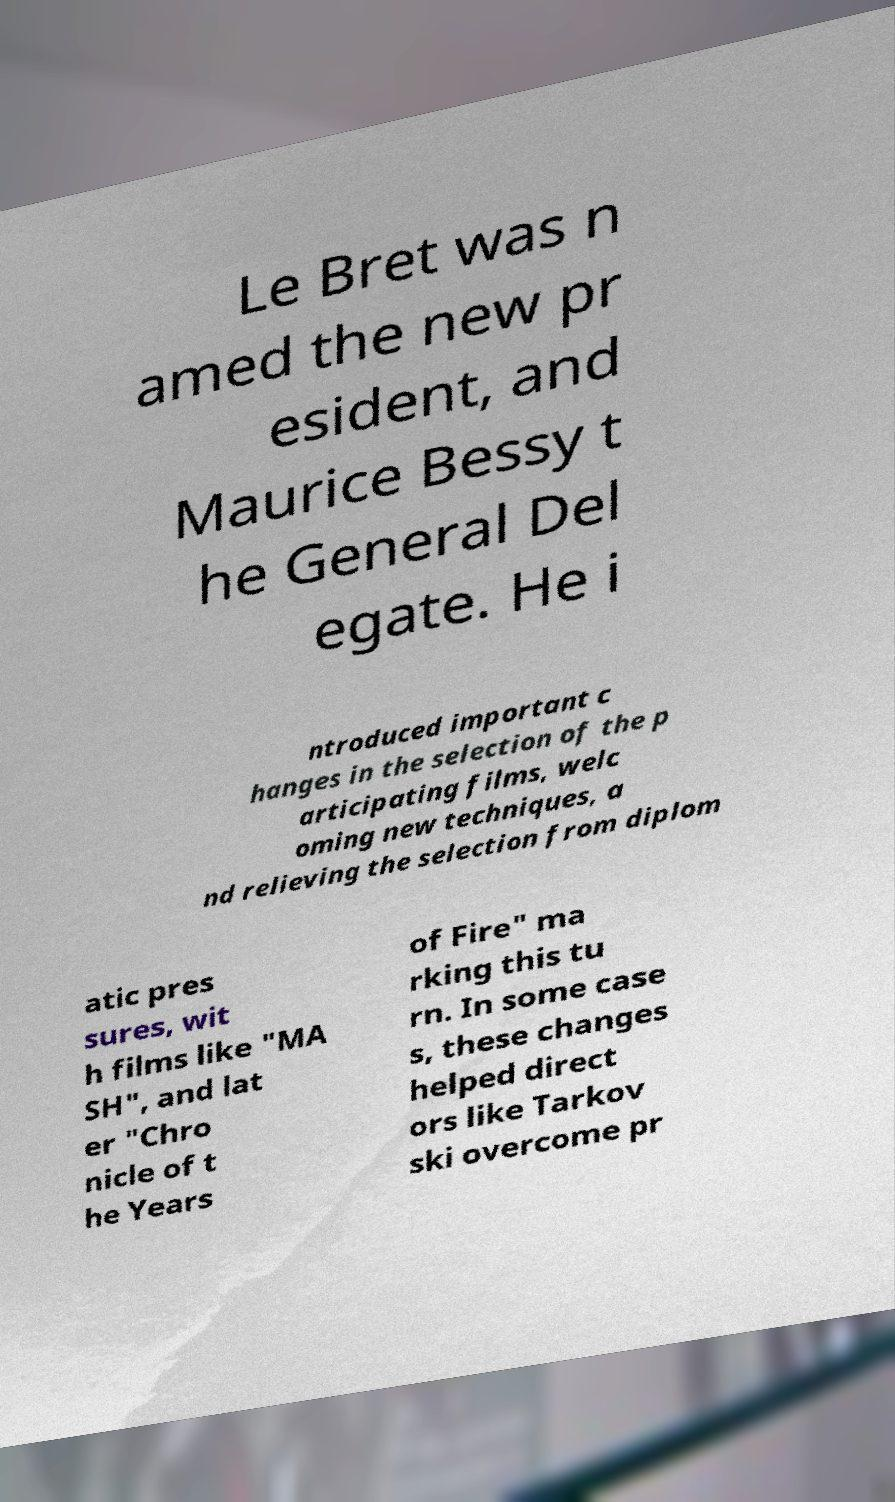Could you assist in decoding the text presented in this image and type it out clearly? Le Bret was n amed the new pr esident, and Maurice Bessy t he General Del egate. He i ntroduced important c hanges in the selection of the p articipating films, welc oming new techniques, a nd relieving the selection from diplom atic pres sures, wit h films like "MA SH", and lat er "Chro nicle of t he Years of Fire" ma rking this tu rn. In some case s, these changes helped direct ors like Tarkov ski overcome pr 